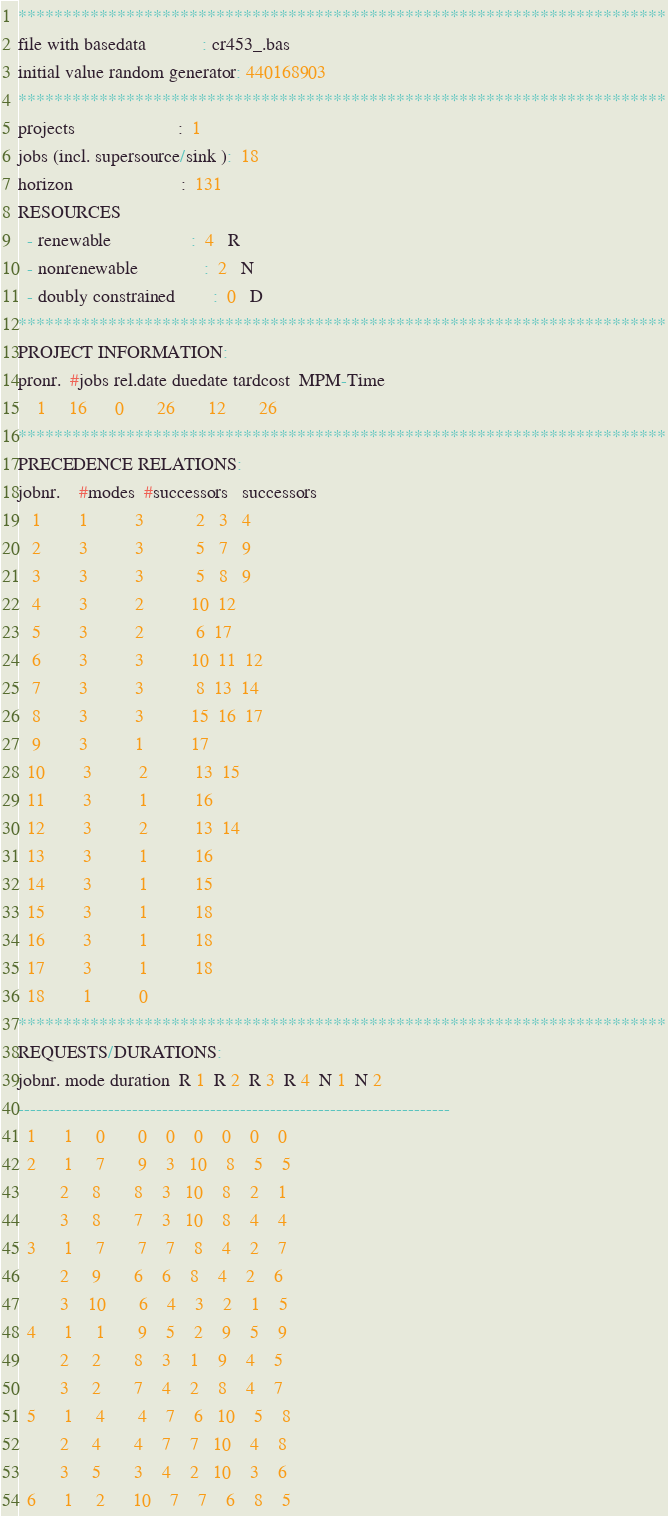Convert code to text. <code><loc_0><loc_0><loc_500><loc_500><_ObjectiveC_>************************************************************************
file with basedata            : cr453_.bas
initial value random generator: 440168903
************************************************************************
projects                      :  1
jobs (incl. supersource/sink ):  18
horizon                       :  131
RESOURCES
  - renewable                 :  4   R
  - nonrenewable              :  2   N
  - doubly constrained        :  0   D
************************************************************************
PROJECT INFORMATION:
pronr.  #jobs rel.date duedate tardcost  MPM-Time
    1     16      0       26       12       26
************************************************************************
PRECEDENCE RELATIONS:
jobnr.    #modes  #successors   successors
   1        1          3           2   3   4
   2        3          3           5   7   9
   3        3          3           5   8   9
   4        3          2          10  12
   5        3          2           6  17
   6        3          3          10  11  12
   7        3          3           8  13  14
   8        3          3          15  16  17
   9        3          1          17
  10        3          2          13  15
  11        3          1          16
  12        3          2          13  14
  13        3          1          16
  14        3          1          15
  15        3          1          18
  16        3          1          18
  17        3          1          18
  18        1          0        
************************************************************************
REQUESTS/DURATIONS:
jobnr. mode duration  R 1  R 2  R 3  R 4  N 1  N 2
------------------------------------------------------------------------
  1      1     0       0    0    0    0    0    0
  2      1     7       9    3   10    8    5    5
         2     8       8    3   10    8    2    1
         3     8       7    3   10    8    4    4
  3      1     7       7    7    8    4    2    7
         2     9       6    6    8    4    2    6
         3    10       6    4    3    2    1    5
  4      1     1       9    5    2    9    5    9
         2     2       8    3    1    9    4    5
         3     2       7    4    2    8    4    7
  5      1     4       4    7    6   10    5    8
         2     4       4    7    7   10    4    8
         3     5       3    4    2   10    3    6
  6      1     2      10    7    7    6    8    5</code> 